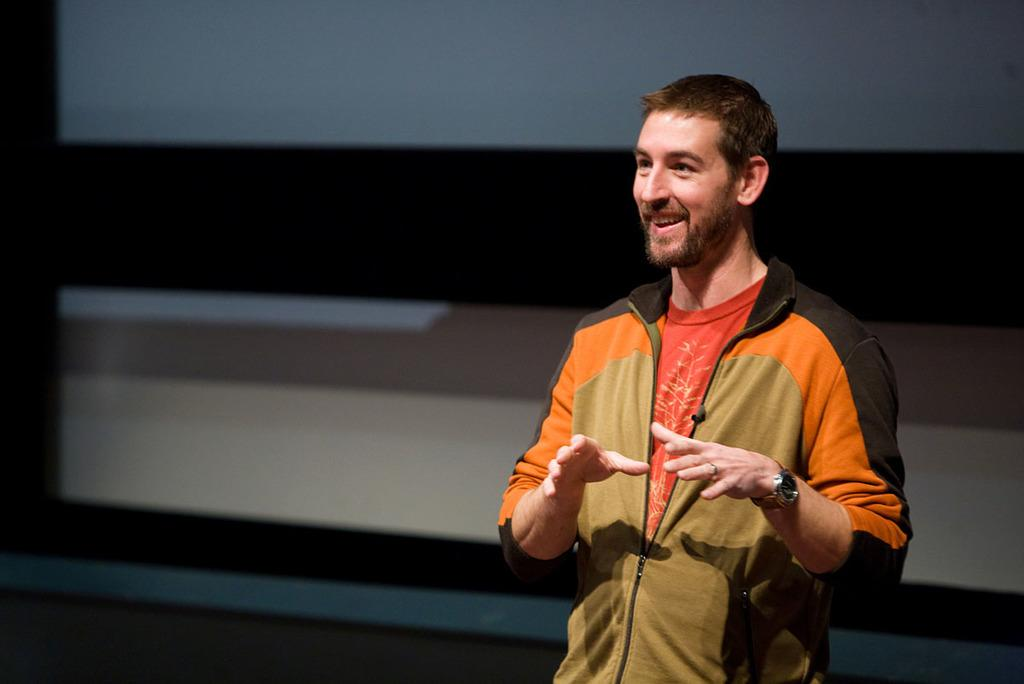What is the main subject in the foreground of the image? There is a man standing in the foreground of the image. What is the man doing in the image? The man appears to be talking. What can be seen in the background of the image? There is a wall visible in the background of the image. What type of suit is the man wearing in the image? There is no information about the man's clothing in the image, so it cannot be determined if he is wearing a suit. How many geese are present in the image? There are no geese present in the image. 